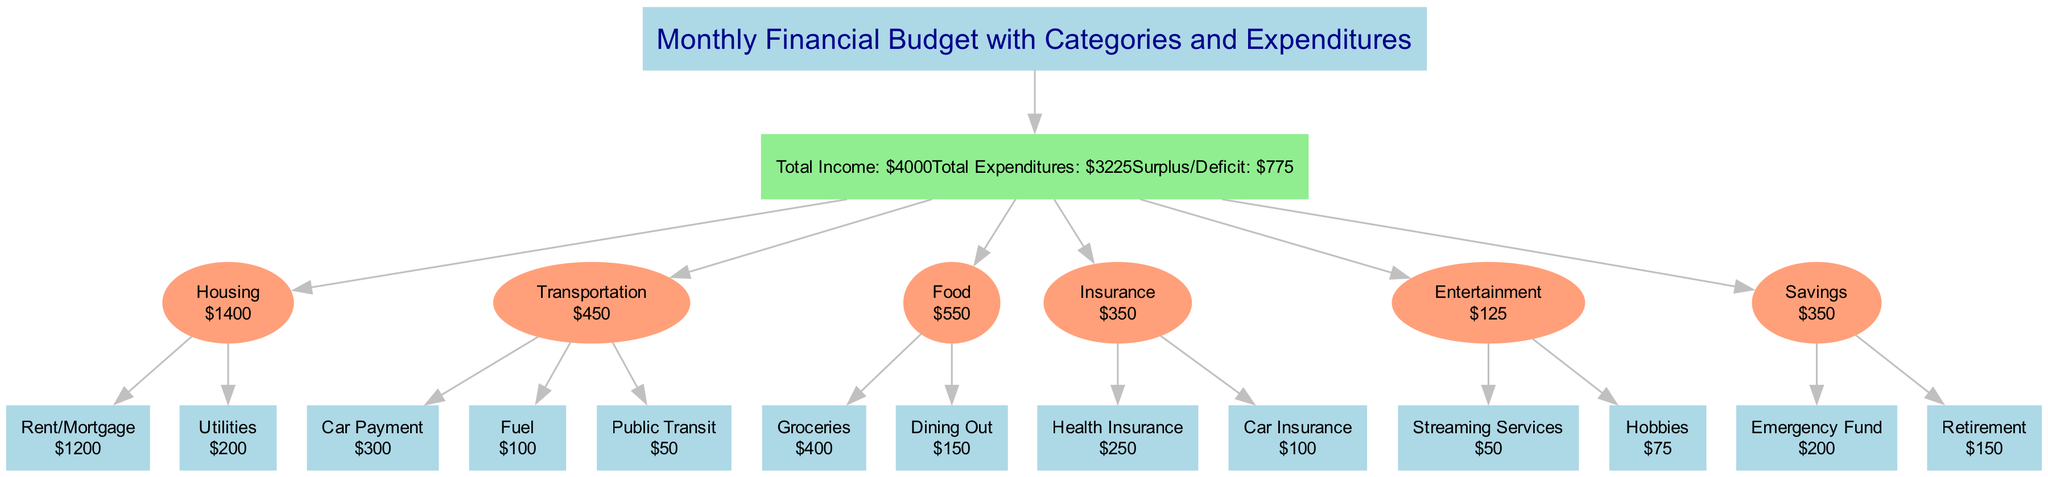What is the total income represented in the diagram? The diagram lists the total income as one of the primary pieces of information connected to the title node. By locating that node, we find that the total income is $4000.
Answer: $4000 How much was spent on Housing? To find the expenditure for Housing, we can look for the Housing category in the diagram. The elements within this category are Rent/Mortgage and Utilities. Adding both expenditures, $1200 (Rent/Mortgage) + $200 (Utilities) gives us a total of $1400 for Housing.
Answer: $1400 What is the expenditure for Entertainment? The Entertainment category contains two expenditures: Streaming Services and Hobbies. Calculating the total by adding these amounts, $50 (Streaming Services) + $75 (Hobbies), results in a total of $125 for Entertainment.
Answer: $125 Which category has the highest total expenditure? To determine which category has the highest total, we compute the total expenditures for each. Housing: $1400, Transportation: $450, Food: $550, Insurance: $350, Entertainment: $125, and Savings: $350. The highest total expenditure is from Housing at $1400.
Answer: Housing What is the surplus or deficit amount? The surplus or deficit is stated clearly in the total node of the diagram. It shows that the total surplus or deficit is $775, indicating a surplus since it is a positive amount.
Answer: $775 Which category has the lowest expenditure? By reviewing the total expenditures for each category, we find that Entertainment has the lowest total of $125 when compared to the others: Housing, Transportation, Food, Insurance, and Savings. Therefore, the category with the lowest expenditure is Entertainment.
Answer: Entertainment How many expenditure items are listed under Food? The Food category has two specific expenditure items listed: Groceries and Dining Out. Therefore, we can conclude that the total number of expenditure items in the Food category is 2.
Answer: 2 What is the total expenditure for Transportation? To calculate the Transportation total, we add the individual expenditures for Car Payment ($300), Fuel ($100), and Public Transit ($50). Adding these gives $300 + $100 + $50 = $450, which is the total for Transportation.
Answer: $450 